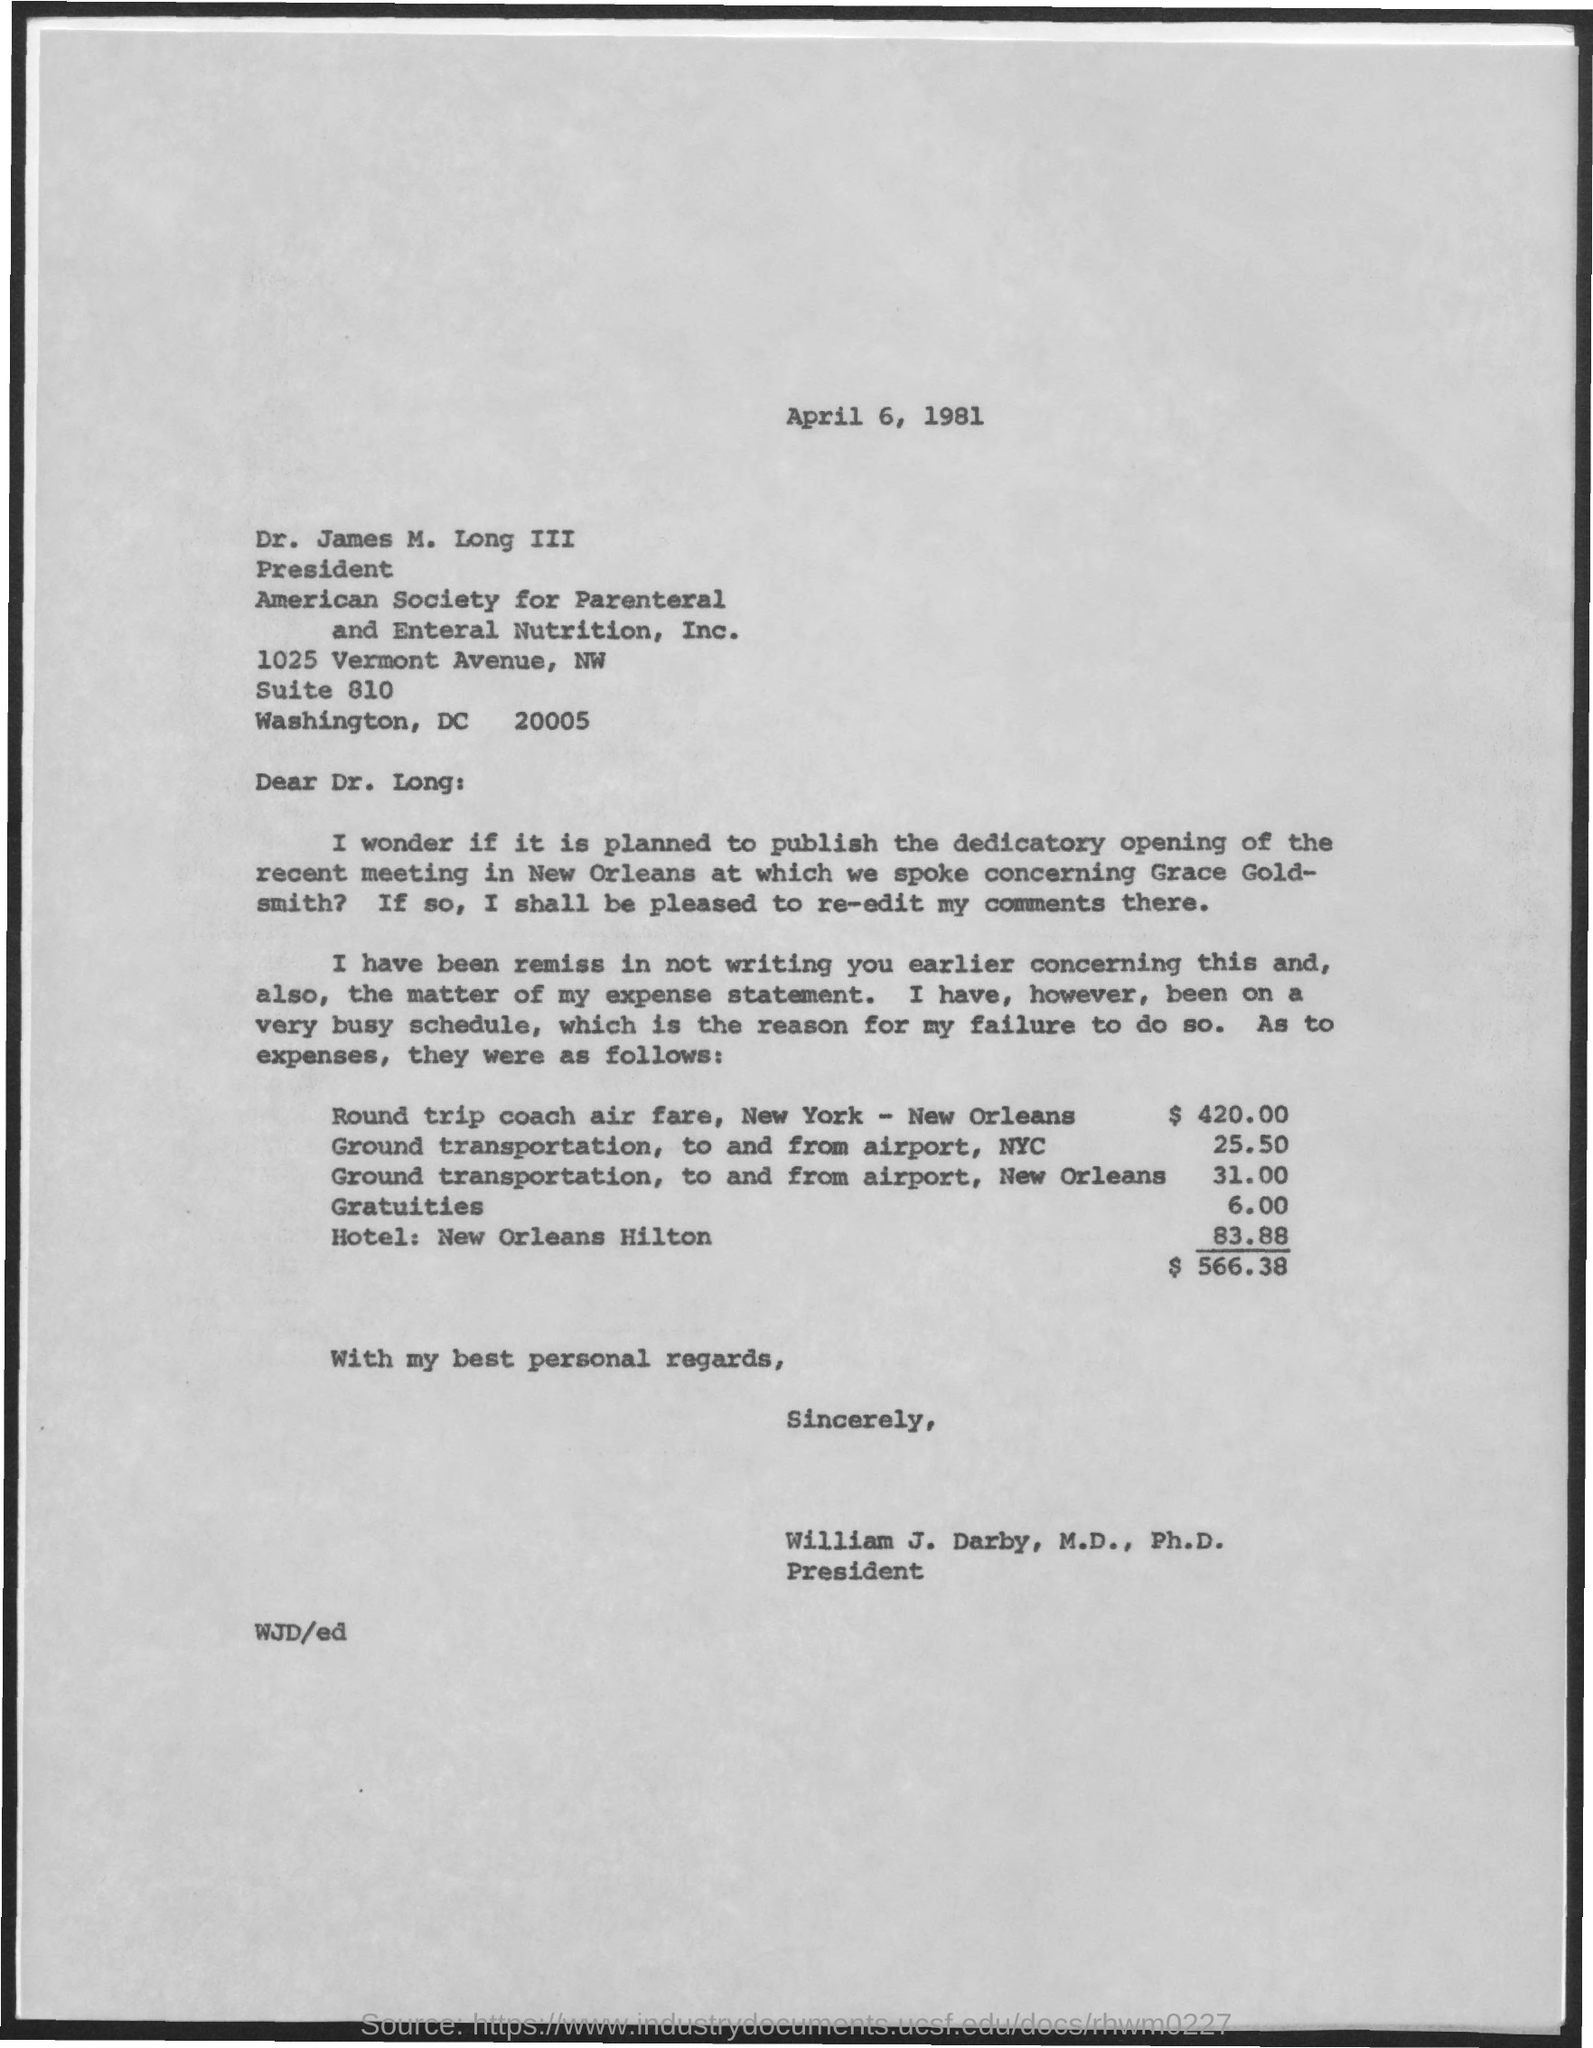Point out several critical features in this image. The total expenses amount to $566.38. 